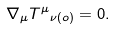<formula> <loc_0><loc_0><loc_500><loc_500>\nabla _ { \mu } { T ^ { \mu } } _ { \nu ( o ) } = 0 .</formula> 